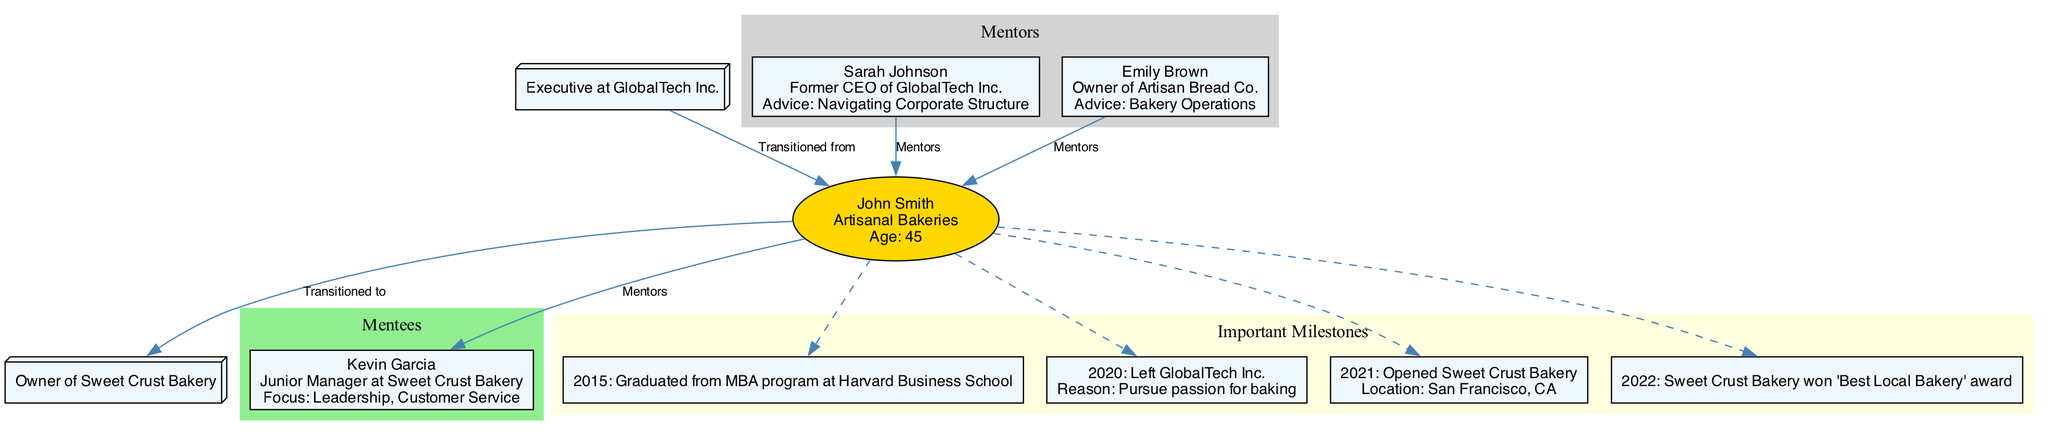What is the name of the main person in the diagram? The main person node in the diagram is labeled "John Smith." This is directly stated in the node's text, which includes his name along with other details.
Answer: John Smith What is the passion of John Smith? The diagram indicates that John Smith's passion is "Artisanal Bakeries," which is stated in the same node as his name.
Answer: Artisanal Bakeries How many mentors does John Smith have? Counting the nodes in the "Mentors" subgraph, there are two distinct mentors listed: Sarah Johnson and Emily Brown.
Answer: 2 What advice did Sarah Johnson give? Within the node for Sarah Johnson, her advice is clearly listed as "Navigating Corporate Structure." This is visible when reviewing the details of the mentor's node.
Answer: Navigating Corporate Structure What year did John Smith graduate from Harvard Business School? In the milestones section, the event stating "Graduated from MBA program at Harvard Business School" is marked with the year 2015. This is found in the appropriate node for important milestones.
Answer: 2015 Who is John Smith's mentee? The diagram lists Kevin Garcia as the only mentee under John Smith, as indicated in the "Mentees" cluster. This information is straightforwardly presented.
Answer: Kevin Garcia What was the reason John Smith left GlobalTech Inc.? The diagram specifies the reason for leaving GlobalTech Inc. in the milestone that reads "Left GlobalTech Inc." followed by "Reason: Pursue passion for baking."
Answer: Pursue passion for baking In what year did Sweet Crust Bakery open? The relevant milestone states, "Opened Sweet Crust Bakery" and is dated in the year 2021. This information can be extracted directly from the milestones node.
Answer: 2021 What role does Kevin Garcia hold at Sweet Crust Bakery? Within the mentee's node for Kevin Garcia, his role is clearly displayed as "Junior Manager at Sweet Crust Bakery," making it easy to find.
Answer: Junior Manager 